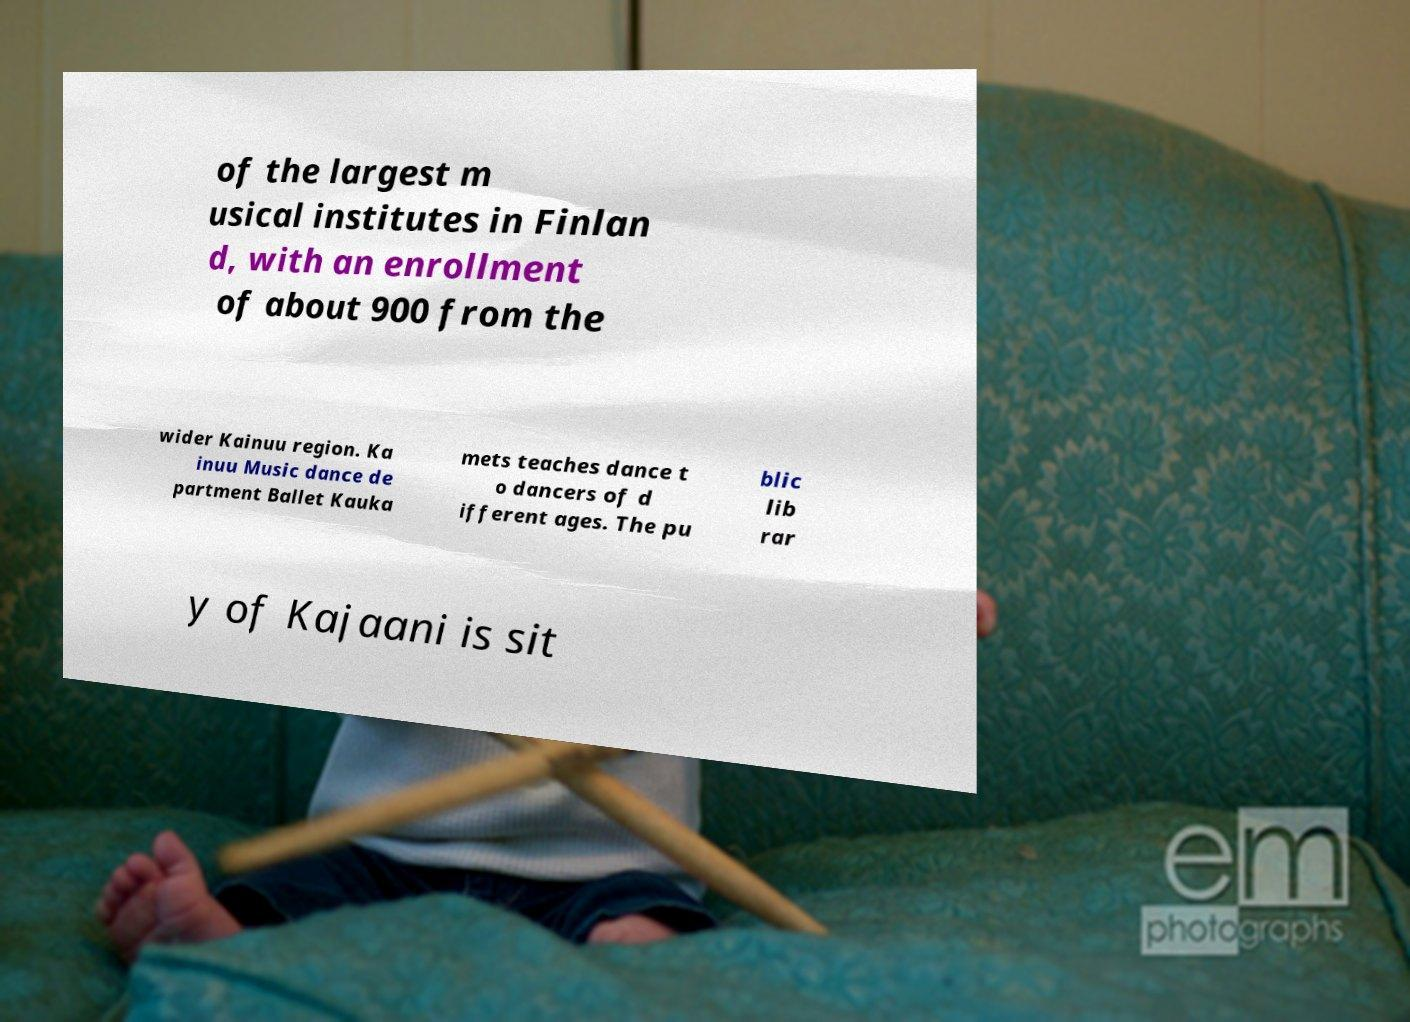What messages or text are displayed in this image? I need them in a readable, typed format. of the largest m usical institutes in Finlan d, with an enrollment of about 900 from the wider Kainuu region. Ka inuu Music dance de partment Ballet Kauka mets teaches dance t o dancers of d ifferent ages. The pu blic lib rar y of Kajaani is sit 